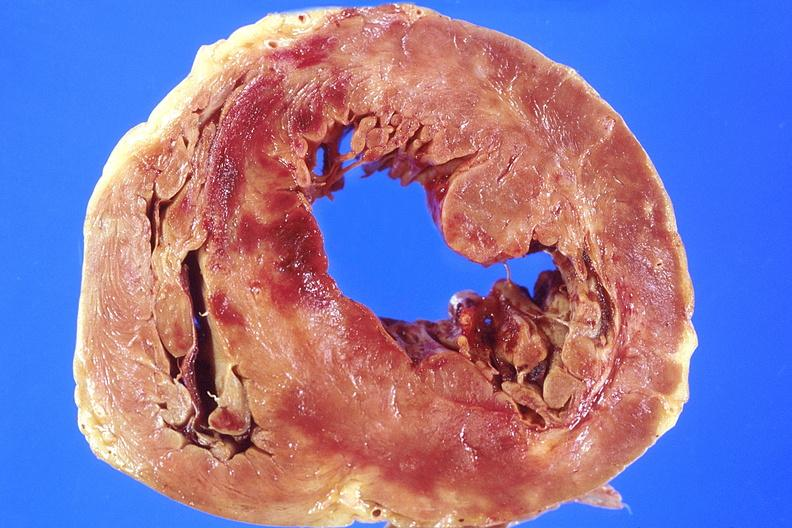what is present?
Answer the question using a single word or phrase. Cardiovascular 